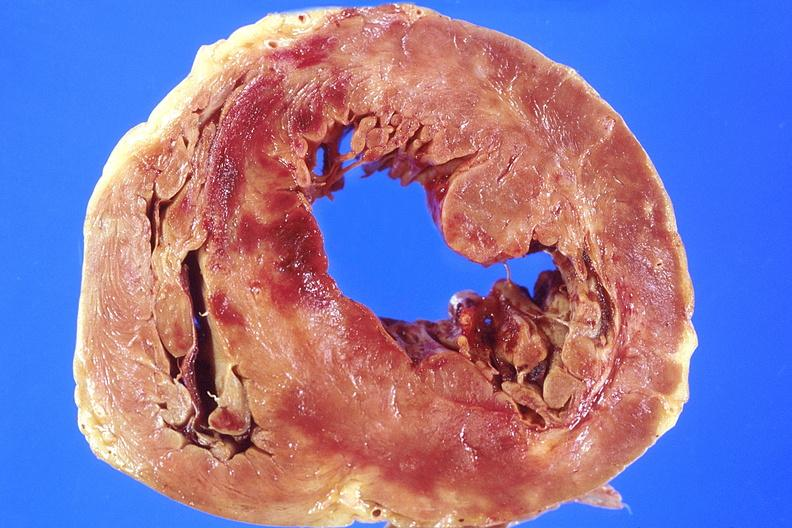what is present?
Answer the question using a single word or phrase. Cardiovascular 